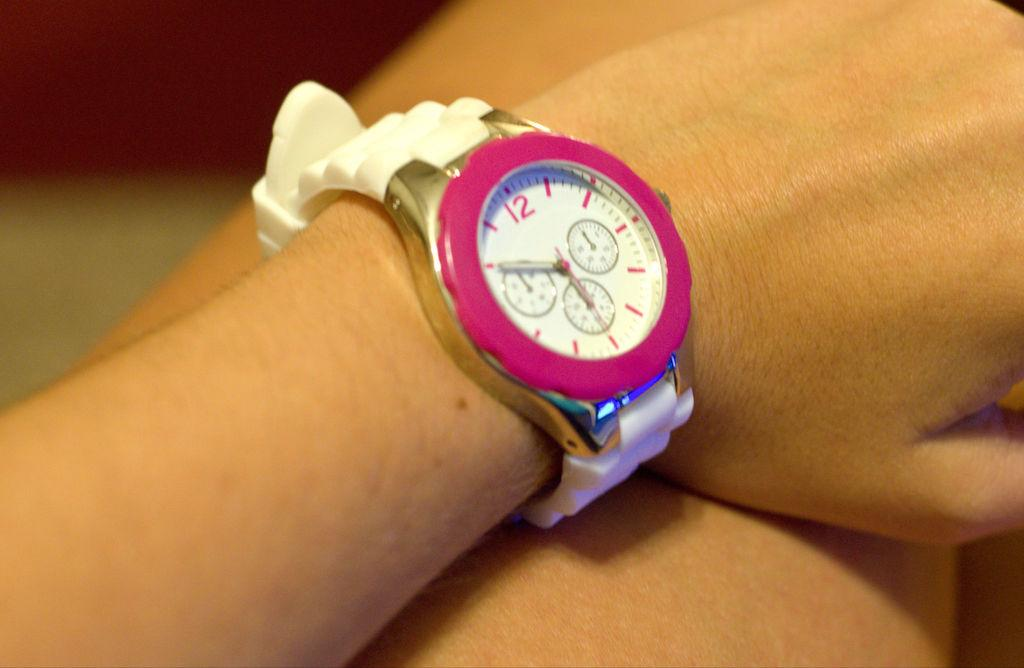Provide a one-sentence caption for the provided image. A girl is wearing a watch that is set to 5:50. 